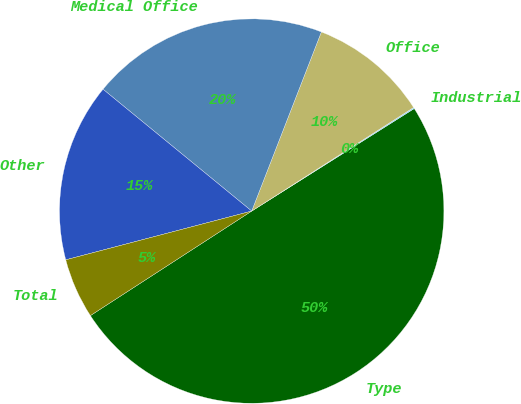Convert chart to OTSL. <chart><loc_0><loc_0><loc_500><loc_500><pie_chart><fcel>Type<fcel>Industrial<fcel>Office<fcel>Medical Office<fcel>Other<fcel>Total<nl><fcel>49.81%<fcel>0.1%<fcel>10.04%<fcel>19.98%<fcel>15.01%<fcel>5.07%<nl></chart> 